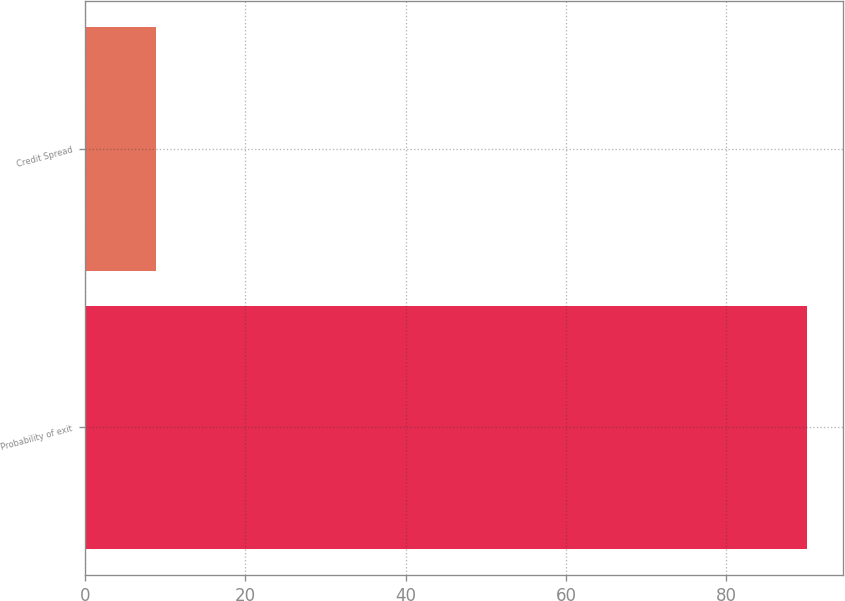<chart> <loc_0><loc_0><loc_500><loc_500><bar_chart><fcel>Probability of exit<fcel>Credit Spread<nl><fcel>90<fcel>8.9<nl></chart> 